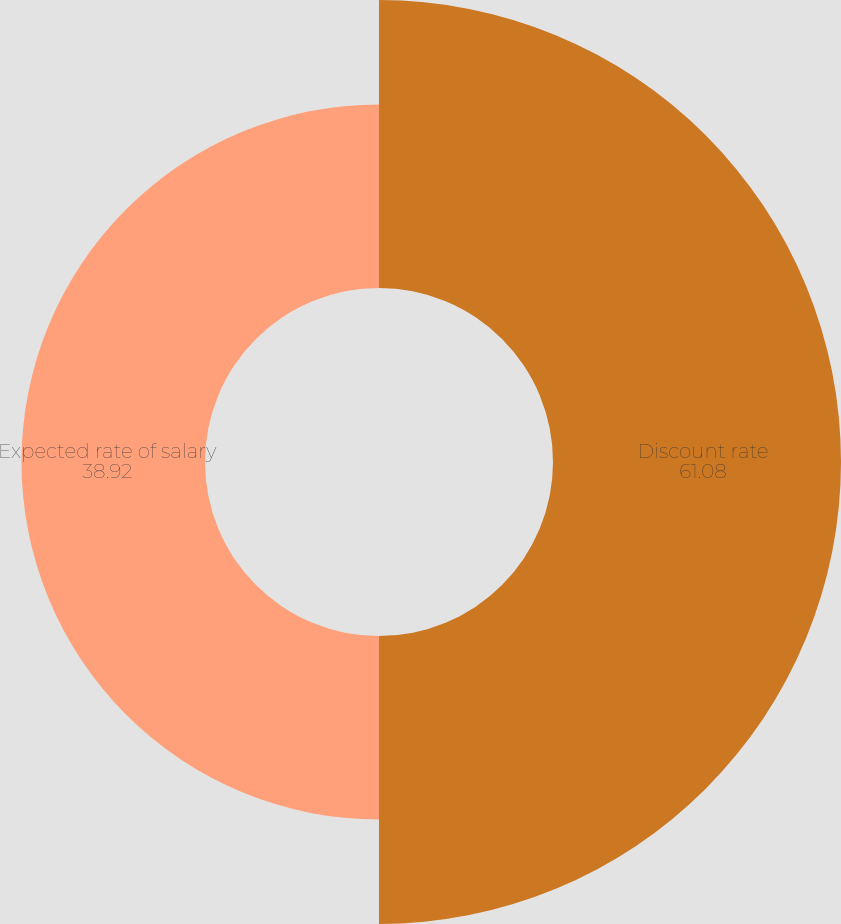<chart> <loc_0><loc_0><loc_500><loc_500><pie_chart><fcel>Discount rate<fcel>Expected rate of salary<nl><fcel>61.08%<fcel>38.92%<nl></chart> 